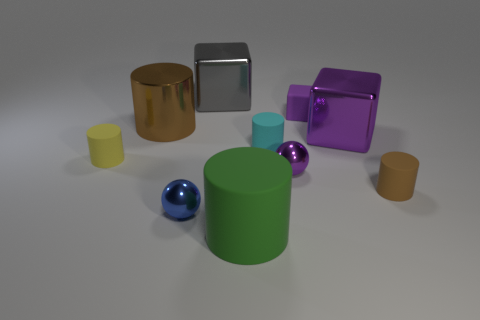What material is the purple object that is the same size as the green rubber object?
Offer a terse response. Metal. What is the material of the large cylinder that is in front of the big thing that is to the left of the gray object?
Make the answer very short. Rubber. Is the shape of the thing to the left of the large metal cylinder the same as  the green matte thing?
Ensure brevity in your answer.  Yes. What color is the large cylinder that is the same material as the tiny cyan thing?
Make the answer very short. Green. There is a cylinder that is behind the big purple shiny thing; what is its material?
Offer a terse response. Metal. Do the gray shiny thing and the purple object behind the metal cylinder have the same shape?
Offer a very short reply. Yes. There is a cylinder that is both on the left side of the large green cylinder and in front of the big brown object; what material is it?
Your response must be concise. Rubber. There is a block that is the same size as the gray metallic thing; what is its color?
Provide a short and direct response. Purple. Is the small yellow cylinder made of the same material as the purple sphere in front of the big purple object?
Provide a short and direct response. No. How many other things are there of the same size as the green matte thing?
Offer a terse response. 3. 